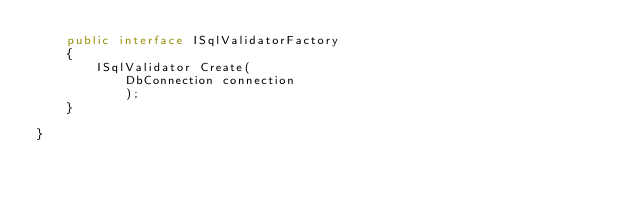Convert code to text. <code><loc_0><loc_0><loc_500><loc_500><_C#_>    public interface ISqlValidatorFactory
    {
        ISqlValidator Create(
            DbConnection connection
            );
    }

}
</code> 